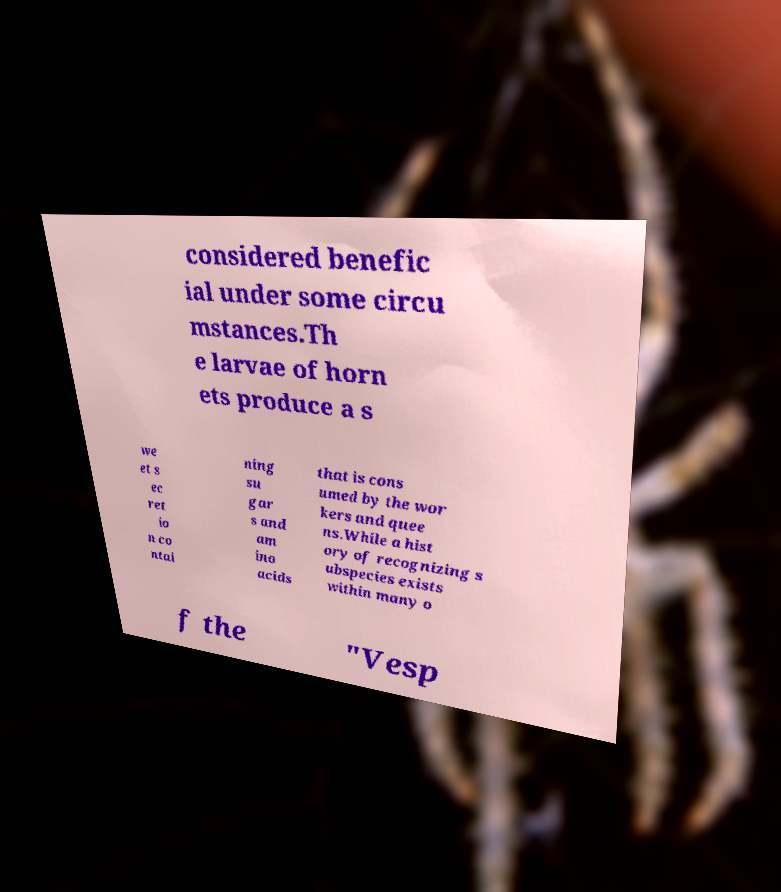Could you assist in decoding the text presented in this image and type it out clearly? considered benefic ial under some circu mstances.Th e larvae of horn ets produce a s we et s ec ret io n co ntai ning su gar s and am ino acids that is cons umed by the wor kers and quee ns.While a hist ory of recognizing s ubspecies exists within many o f the "Vesp 